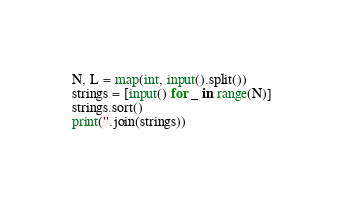<code> <loc_0><loc_0><loc_500><loc_500><_Python_>N, L = map(int, input().split())
strings = [input() for _ in range(N)]
strings.sort()
print(''.join(strings))
</code> 